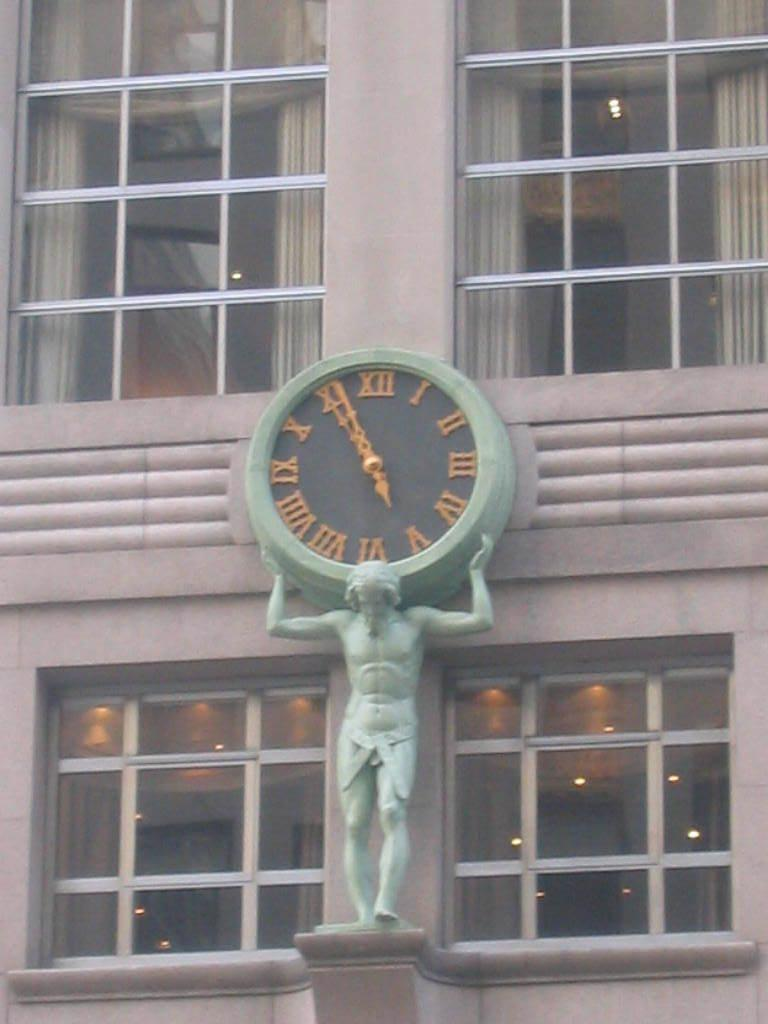What is the main subject of the sculpture in the image? There is a sculpture of a person standing in the image. What time-telling device can be seen in the image? There is a clock in the image. What architectural feature is present in the image? There are windows in the image. What type of structure does the image appear to depict? The image appears to depict a building. What can be seen providing illumination in the image? There are lights visible in the image. What type of glove is being used to rake the plastic in the image? There is no glove, rake, or plastic present in the image. 